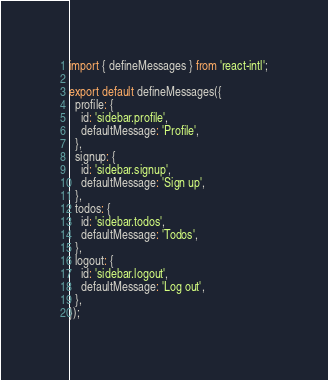Convert code to text. <code><loc_0><loc_0><loc_500><loc_500><_JavaScript_>import { defineMessages } from 'react-intl';

export default defineMessages({
  profile: {
    id: 'sidebar.profile',
    defaultMessage: 'Profile',
  },
  signup: {
    id: 'sidebar.signup',
    defaultMessage: 'Sign up',
  },
  todos: {
    id: 'sidebar.todos',
    defaultMessage: 'Todos',
  },
  logout: {
    id: 'sidebar.logout',
    defaultMessage: 'Log out',
  },
});
</code> 